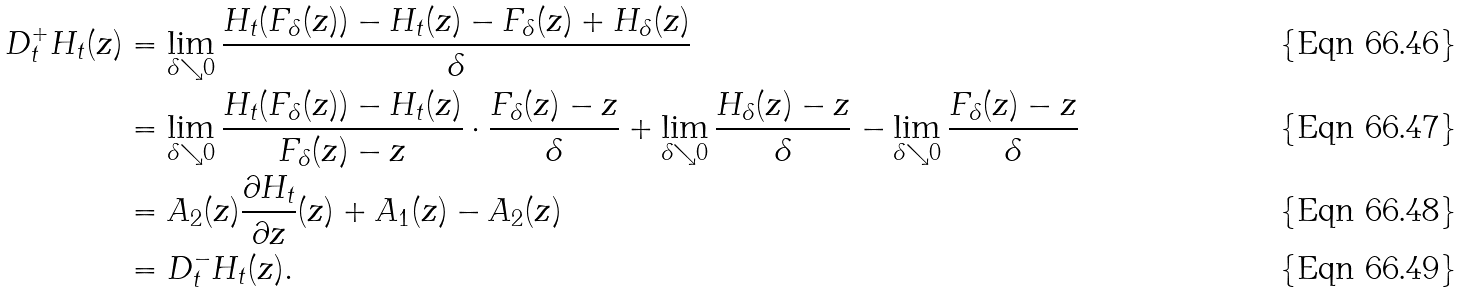Convert formula to latex. <formula><loc_0><loc_0><loc_500><loc_500>D _ { t } ^ { + } H _ { t } ( z ) & = \lim _ { \delta \searrow 0 } \frac { H _ { t } ( F _ { \delta } ( z ) ) - H _ { t } ( z ) - F _ { \delta } ( z ) + H _ { \delta } ( z ) } { \delta } \\ & = \lim _ { \delta \searrow 0 } \frac { H _ { t } ( F _ { \delta } ( z ) ) - H _ { t } ( z ) } { F _ { \delta } ( z ) - z } \cdot \frac { F _ { \delta } ( z ) - z } { \delta } + \lim _ { \delta \searrow 0 } \frac { H _ { \delta } ( z ) - z } { \delta } - \lim _ { \delta \searrow 0 } \frac { F _ { \delta } ( z ) - z } { \delta } \\ & = A _ { 2 } ( z ) \frac { \partial H _ { t } } { \partial z } ( z ) + A _ { 1 } ( z ) - A _ { 2 } ( z ) \\ & = D _ { t } ^ { - } H _ { t } ( z ) .</formula> 